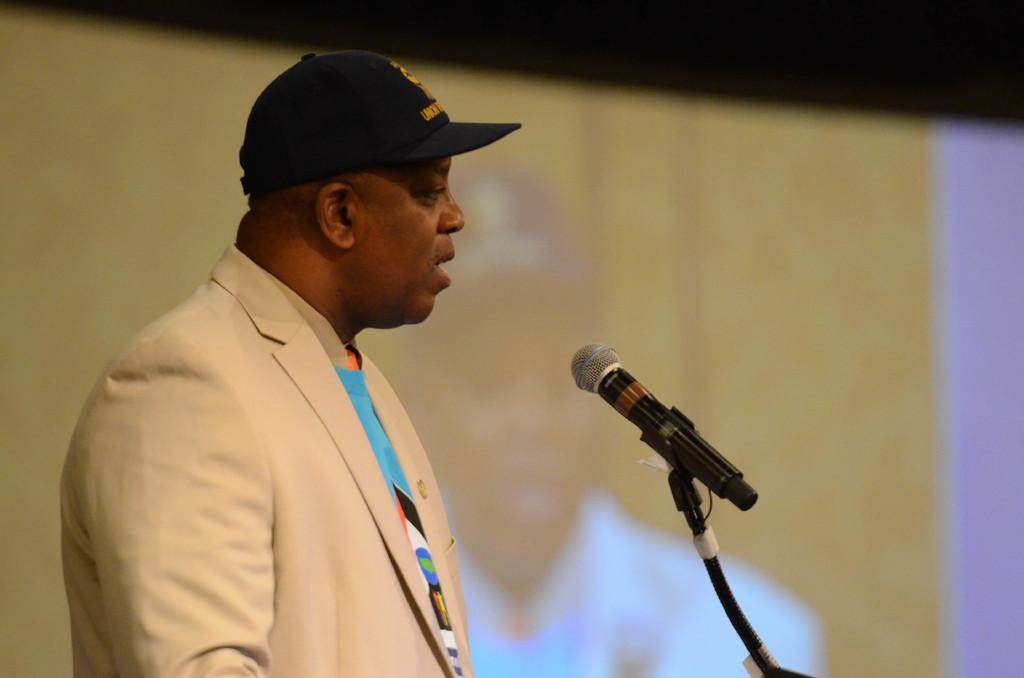Who is the main subject in the image? There is a man in the image. What is the man wearing on his head? The man is wearing a cap. What type of clothing is the man wearing? The man is wearing a cream-colored suit. What is the man doing in the image? The man is talking on a microphone. What type of guitar is the man playing in the image? There is no guitar present in the image; the man is talking on a microphone. What is the man's chin doing in the image? The man's chin is not a separate subject in the image; it is part of the man's face. 